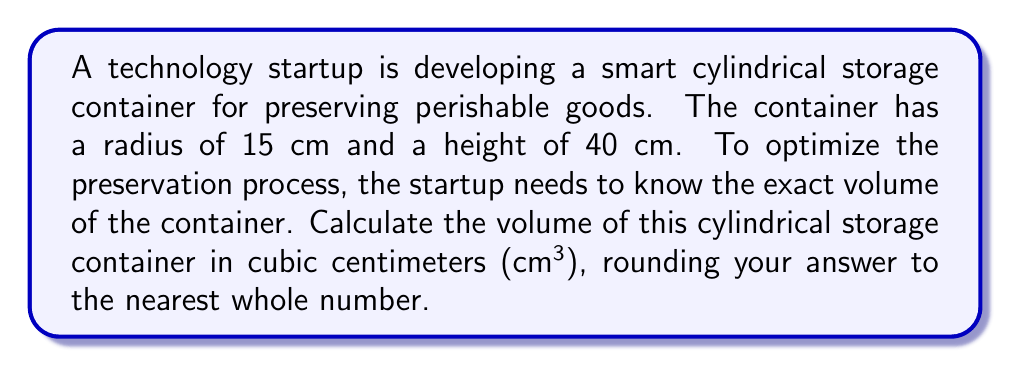Help me with this question. To calculate the volume of a cylindrical container, we use the formula:

$$V = \pi r^2 h$$

Where:
$V$ = volume
$\pi$ = pi (approximately 3.14159)
$r$ = radius of the base
$h$ = height of the cylinder

Given:
$r = 15$ cm
$h = 40$ cm

Let's substitute these values into the formula:

$$V = \pi (15 \text{ cm})^2 (40 \text{ cm})$$

First, calculate the square of the radius:
$15^2 = 225$

Now, our equation looks like this:
$$V = \pi (225 \text{ cm}^2) (40 \text{ cm})$$

Multiply the values inside the parentheses:
$$V = \pi (9000 \text{ cm}^3)$$

Using 3.14159 as an approximation for $\pi$:
$$V \approx 3.14159 \times 9000 \text{ cm}^3$$
$$V \approx 28274.31 \text{ cm}^3$$

Rounding to the nearest whole number:
$$V \approx 28274 \text{ cm}^3$$

[asy]
import geometry;

size(200);
real r = 3;
real h = 8;

path base = circle((0,0), r);
path top = circle((0,h), r);

draw(base);
draw(top);
draw((r,0)--(r,h));
draw((-r,0)--(-r,h));

label("r", (r/2,0), E);
label("h", (r,h/2), E);

draw((0,0)--(r,0), arrow=Arrow(TeXHead));
draw((r,0)--(r,h), arrow=Arrow(TeXHead));
[/asy]
Answer: The volume of the cylindrical storage container is approximately 28274 cm³. 